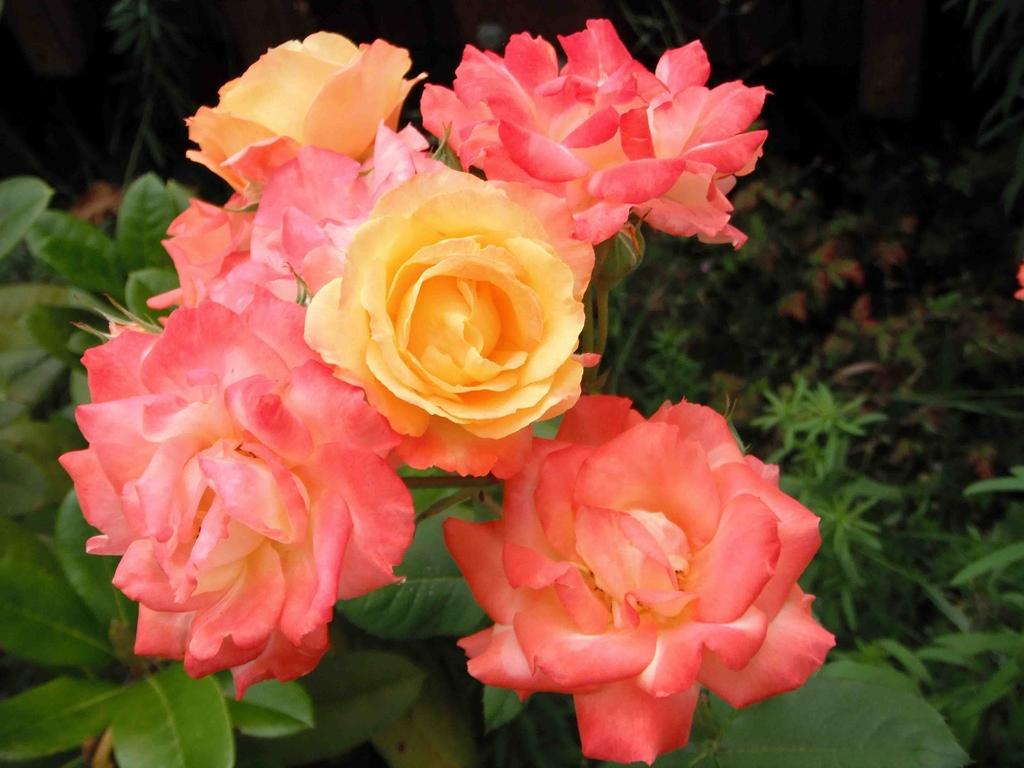What is the main subject in the center of the image? There are flowers in the center of the image. What other elements are present in the image besides the flowers? The image also consists of plants. Can you see a river flowing through the cave in the image? There is no river or cave present in the image; it features flowers and plants. 